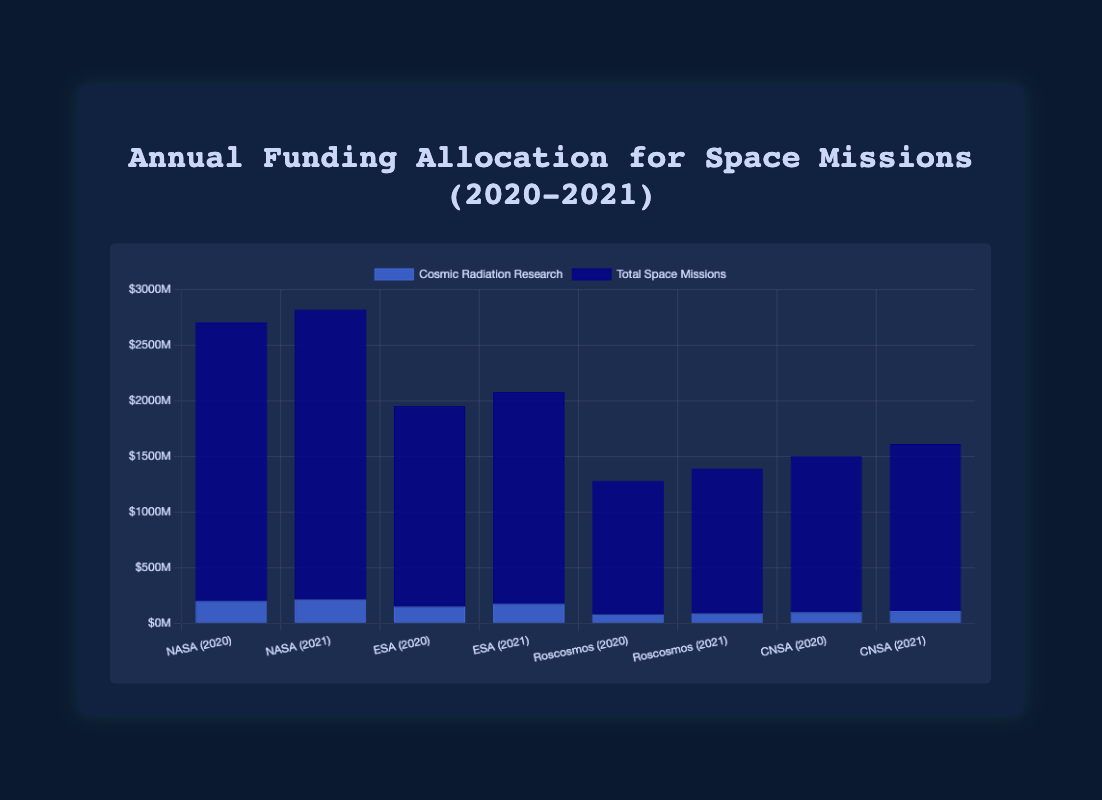Which space organization received the most funding for cosmic radiation research in 2021? Observe the bar heights for "Cosmic Radiation Research" in 2021. NASA has the tallest blue bar with $215M.
Answer: NASA How much more funding did NASA allocate to cosmic radiation research compared to CNSA in 2020? NASA’s funding for cosmic radiation research in 2020 is $200M and CNSA’s is $100M. The difference is $200M - $100M = $100M.
Answer: $100M Which organization had the smallest allocation for cosmic radiation research in 2020 and how much was it? Compare the blue bars for 2020. Roscosmos has the smallest blue bar with $80M.
Answer: Roscosmos, $80M What is the total funding allocated to cosmic radiation research across all organizations in 2021? Add the cosmic radiation research fundings for all organizations in 2021: $215M (NASA) + $175M (ESA) + $90M (Roscosmos) + $110M (CNSA) = $590M.
Answer: $590M Which organization showed the biggest increase in funding for cosmic radiation research from 2020 to 2021? Calculate the increase for each organization: NASA: $215M - $200M = $15M, ESA: $175M - $150M = $25M, Roscosmos: $90M - $80M = $10M, CNSA: $110M - $100M = $10M. ESA has the largest increase at $25M.
Answer: ESA What was the average funding for total space missions across all organizations in 2020? Sum the total space mission fundings for all organizations in 2020: $2500M (NASA) + $1800M (ESA) + $1200M (Roscosmos) + $1400M (CNSA) = $6900M. Divide by 4: $6900M / 4 = $1725M.
Answer: $1725M Compare the percentage of total funding allocated to cosmic radiation research between NASA in 2020 and ESA in 2021. Which was higher? NASA in 2020: ($200M / $2500M) * 100 = 8%, ESA in 2021: ($175M / $1900M) * 100 = 9.21%. ESA in 2021 allocated a higher percentage.
Answer: ESA in 2021 Which organization had the least change in funding for cosmic radiation research from 2020 to 2021? Calculate the change for each organization: NASA: $15M, ESA: $25M, Roscosmos: $10M, CNSA: $10M. Roscosmos and CNSA both have the least change with $10M.
Answer: Roscosmos and CNSA What is the difference between the total space mission funding and cosmic radiation research funding for ESA in 2020? ESA's total space mission funding in 2020 is $1800M and cosmic radiation research funding is $150M. The difference is $1800M - $150M = $1650M.
Answer: $1650M 